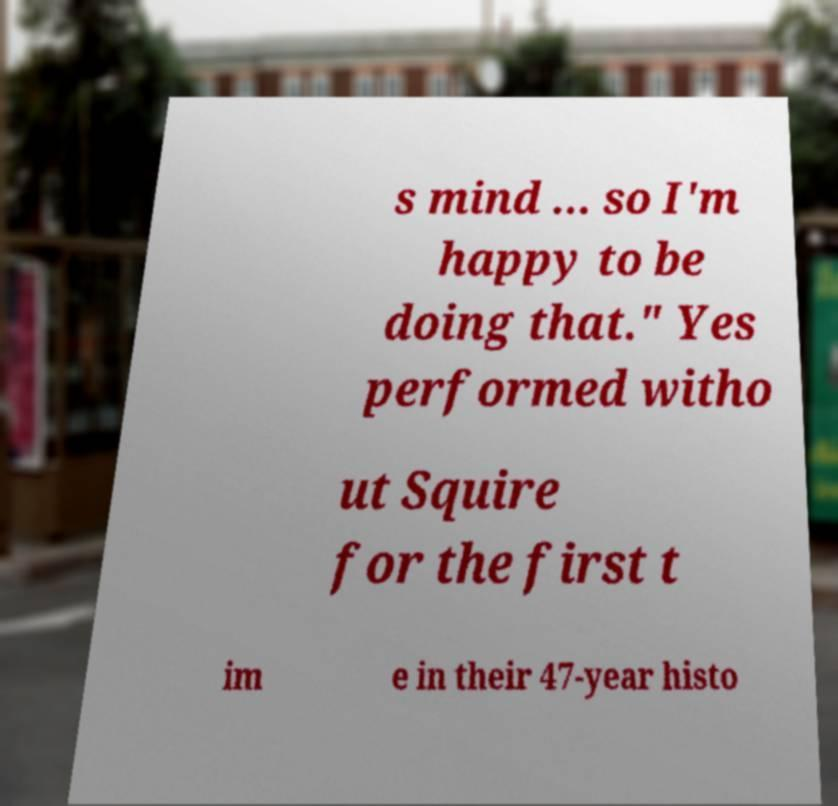For documentation purposes, I need the text within this image transcribed. Could you provide that? s mind ... so I'm happy to be doing that." Yes performed witho ut Squire for the first t im e in their 47-year histo 